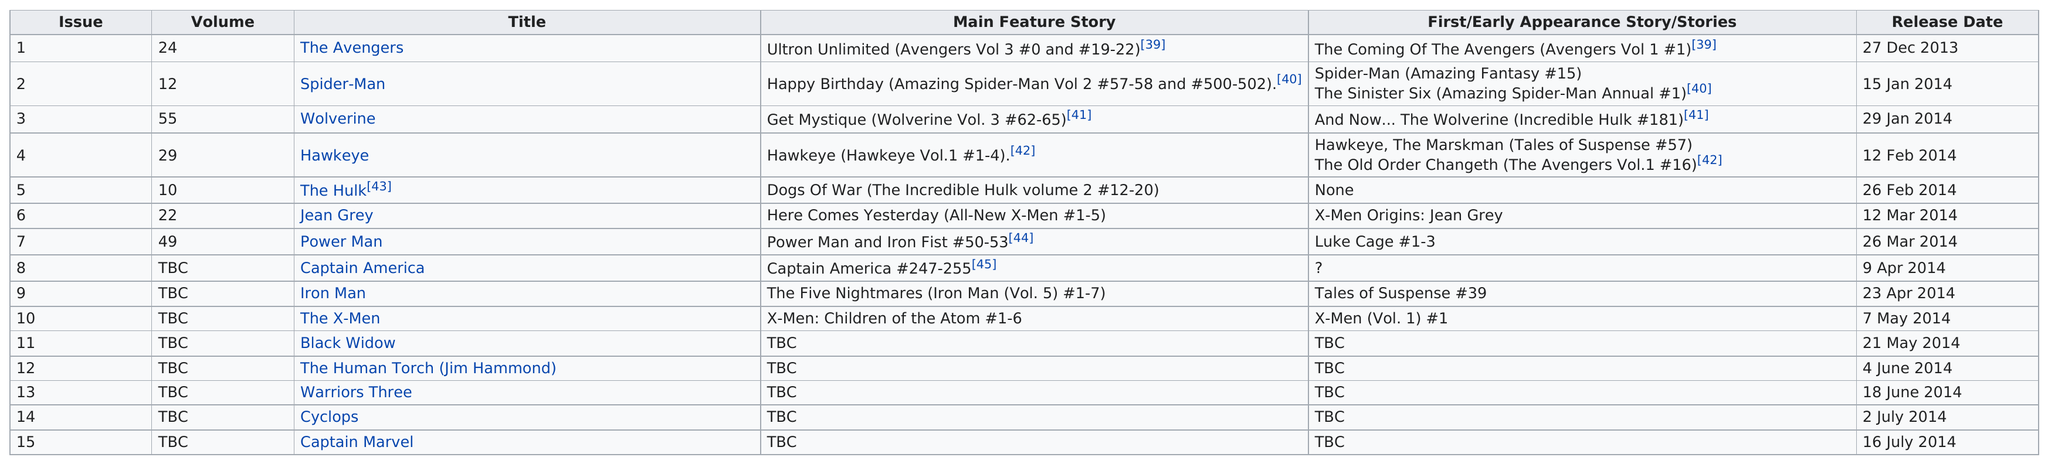List a handful of essential elements in this visual. Name the graphic novel that was released in the same month as the Human Torch, which features the characters known as the Warriors Three. Eight were released after Power Man. On December 27, 2013, the only title being released was 'The Avengers.' The Avengers, the only film released in December 2013, is... Iron Man first appeared in the story titled "The Five Nightmares," which was published in issues #1-7 of Iron Man (Vol. 5). 